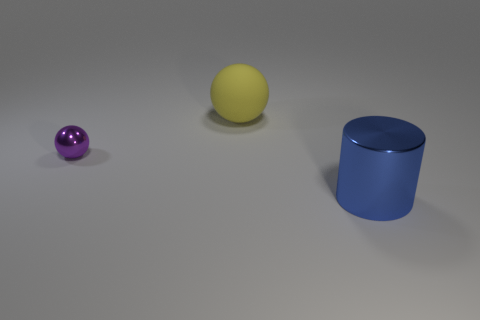Do the large yellow ball and the object in front of the tiny purple shiny ball have the same material?
Provide a succinct answer. No. Are there any large balls made of the same material as the yellow object?
Make the answer very short. No. How many things are either objects to the right of the purple sphere or big things that are in front of the yellow object?
Your response must be concise. 2. Is the shape of the large matte thing the same as the metallic object that is behind the metal cylinder?
Offer a terse response. Yes. What number of other things are the same shape as the yellow rubber thing?
Ensure brevity in your answer.  1. How many objects are either tiny purple objects or blue metallic cylinders?
Offer a terse response. 2. Is the big metal cylinder the same color as the big matte sphere?
Give a very brief answer. No. Is there anything else that is the same size as the purple ball?
Offer a terse response. No. There is a thing that is left of the large object on the left side of the big blue metallic thing; what is its shape?
Keep it short and to the point. Sphere. Is the number of small rubber cylinders less than the number of balls?
Provide a succinct answer. Yes. 